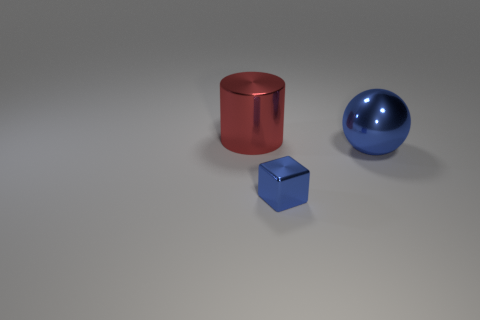Is there anything else that is the same size as the metallic block?
Provide a short and direct response. No. There is a thing to the right of the blue shiny cube; does it have the same color as the cube?
Keep it short and to the point. Yes. What number of other objects are there of the same material as the blue block?
Ensure brevity in your answer.  2. There is a metal object that is both behind the small metallic cube and in front of the big metal cylinder; what is its size?
Give a very brief answer. Large. There is a large thing behind the large shiny object to the right of the big red shiny thing; what is its shape?
Your answer should be very brief. Cylinder. Is there anything else that has the same shape as the big blue metallic object?
Provide a succinct answer. No. Is the number of metal blocks in front of the tiny blue shiny cube the same as the number of large blue things?
Make the answer very short. No. There is a large ball; is it the same color as the small metal thing on the left side of the big ball?
Make the answer very short. Yes. There is a thing that is behind the small cube and right of the red thing; what is its color?
Your response must be concise. Blue. What number of red cylinders are on the left side of the large metal object that is on the right side of the red thing?
Your answer should be compact. 1. 